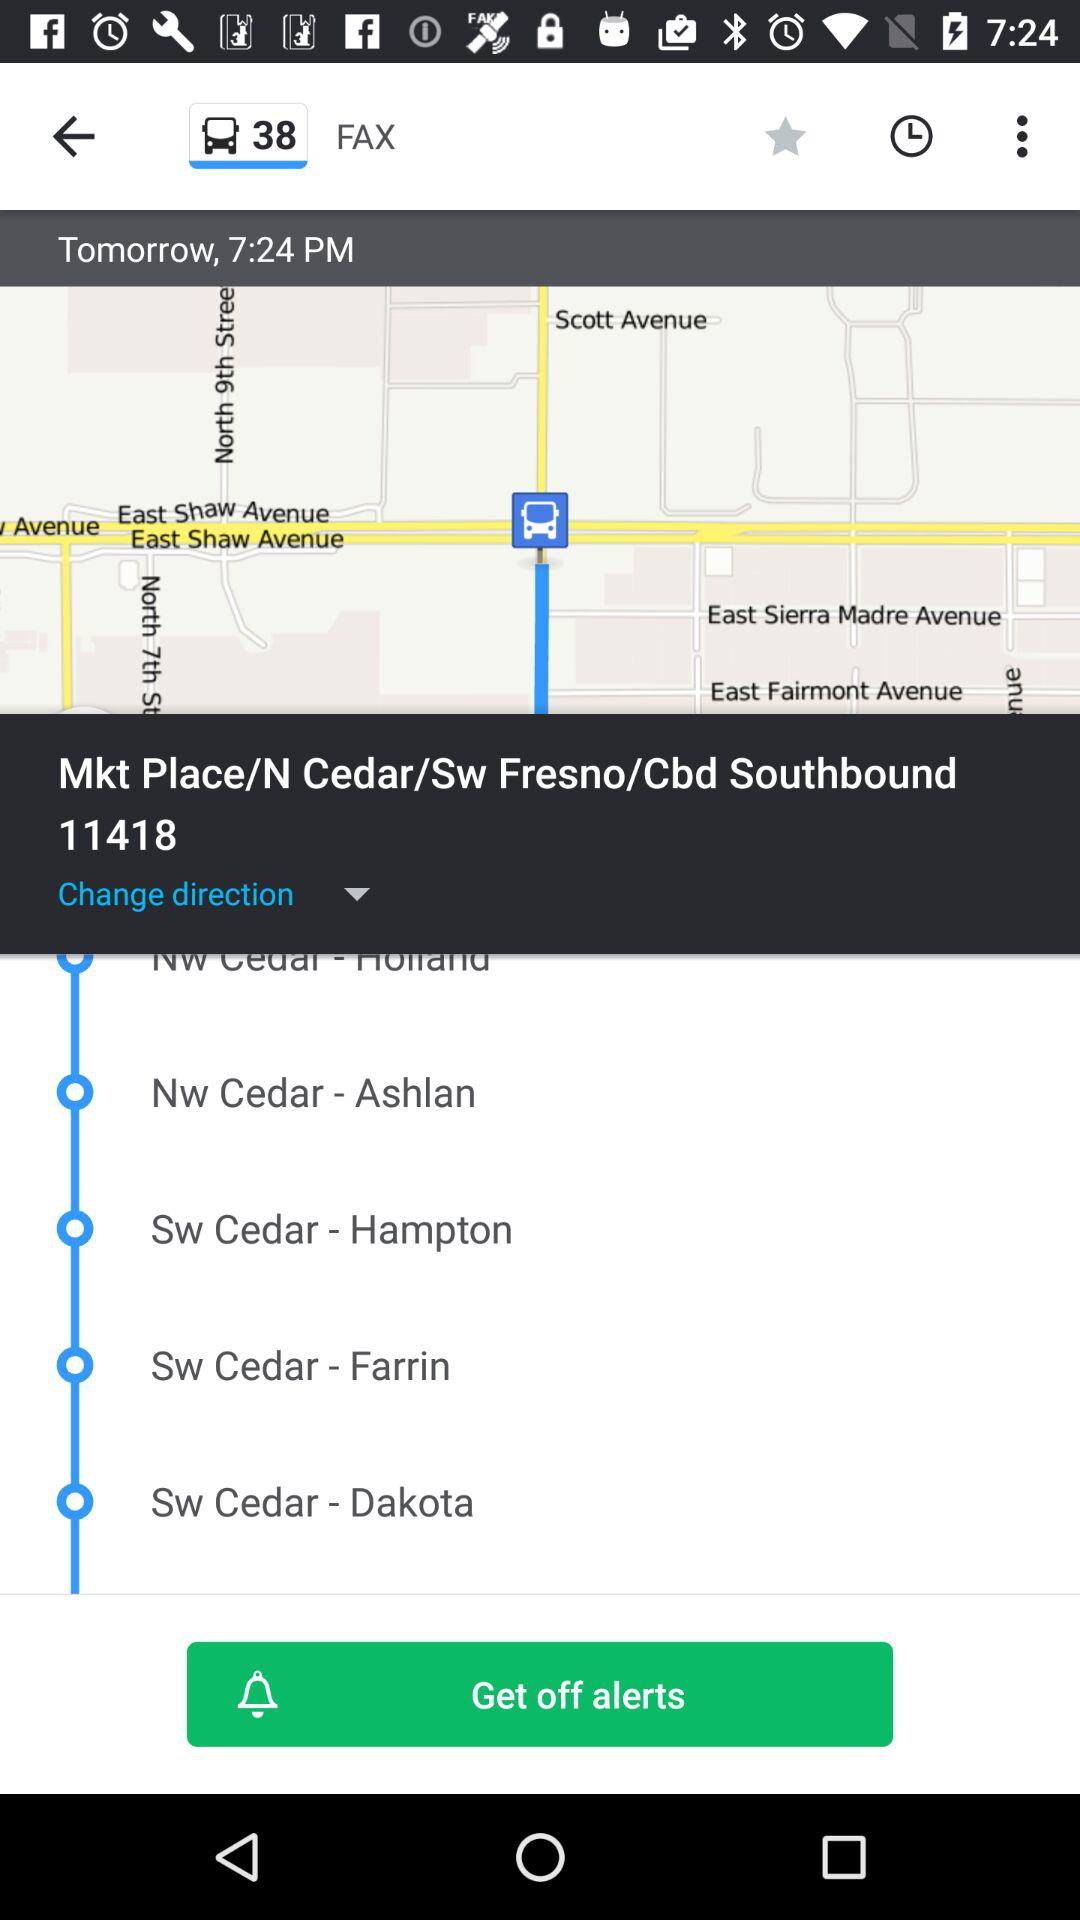What is the selected location? The selected location is Mkt Place/N Cedar/Sw Fresno/Cbd Southbound 11418. 